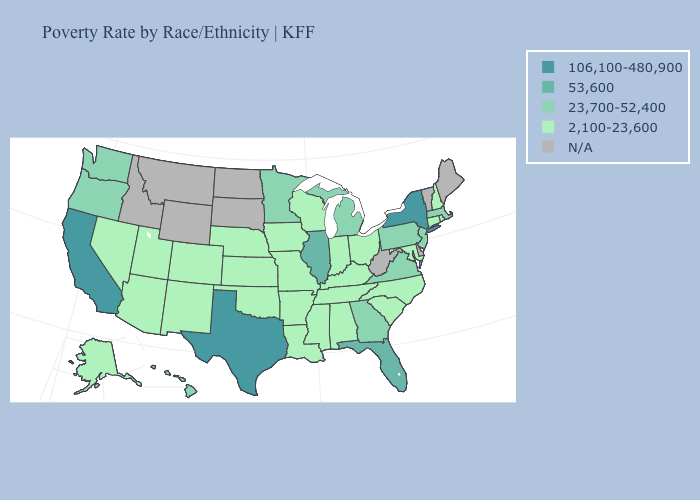Is the legend a continuous bar?
Answer briefly. No. Does the first symbol in the legend represent the smallest category?
Answer briefly. No. Does the first symbol in the legend represent the smallest category?
Write a very short answer. No. Does Texas have the highest value in the USA?
Answer briefly. Yes. Is the legend a continuous bar?
Be succinct. No. What is the highest value in states that border Massachusetts?
Give a very brief answer. 106,100-480,900. How many symbols are there in the legend?
Concise answer only. 5. Among the states that border Georgia , which have the lowest value?
Quick response, please. Alabama, North Carolina, South Carolina, Tennessee. What is the value of Louisiana?
Keep it brief. 2,100-23,600. What is the value of Wisconsin?
Keep it brief. 2,100-23,600. What is the value of Indiana?
Keep it brief. 2,100-23,600. Does Oregon have the lowest value in the West?
Be succinct. No. What is the value of Utah?
Be succinct. 2,100-23,600. Among the states that border Mississippi , which have the lowest value?
Be succinct. Alabama, Arkansas, Louisiana, Tennessee. 